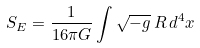<formula> <loc_0><loc_0><loc_500><loc_500>S _ { E } = \frac { 1 } { 1 6 \pi G } \int \sqrt { - g } \, R \, d ^ { 4 } x</formula> 